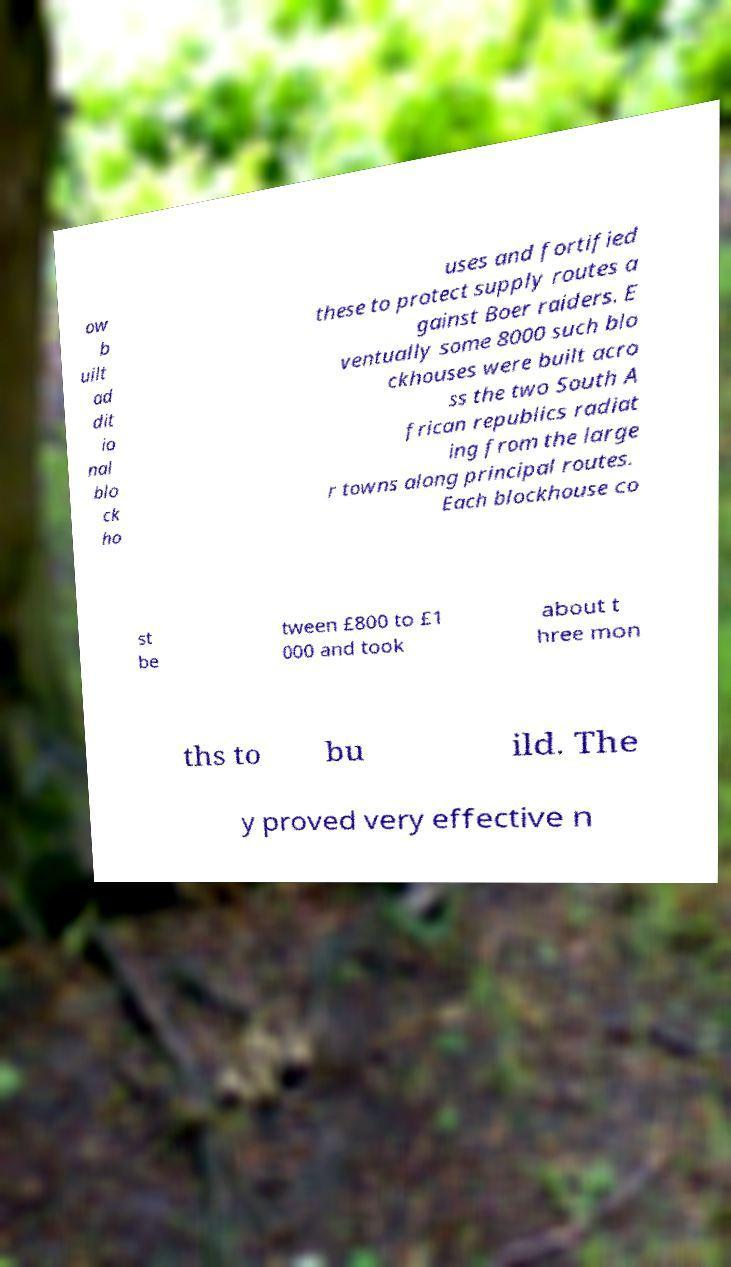Please read and relay the text visible in this image. What does it say? ow b uilt ad dit io nal blo ck ho uses and fortified these to protect supply routes a gainst Boer raiders. E ventually some 8000 such blo ckhouses were built acro ss the two South A frican republics radiat ing from the large r towns along principal routes. Each blockhouse co st be tween £800 to £1 000 and took about t hree mon ths to bu ild. The y proved very effective n 